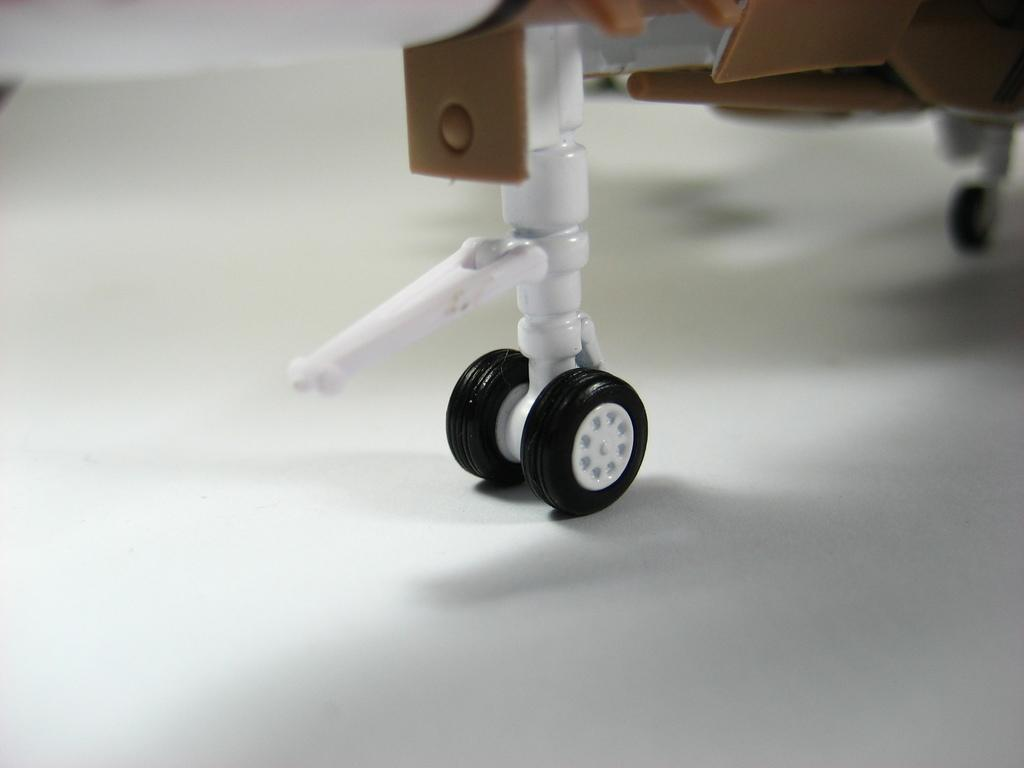What is placed on the floor in the image? There is a rod on the floor. What else can be seen on the floor in the image? There are wheels on the floor. What type of fire can be seen burning in the field in the image? There is no fire or field present in the image; it only features a rod and wheels on the floor. How many bulbs are hanging from the ceiling in the image? There is no mention of a ceiling or bulbs in the image; it only features a rod and wheels on the floor. 